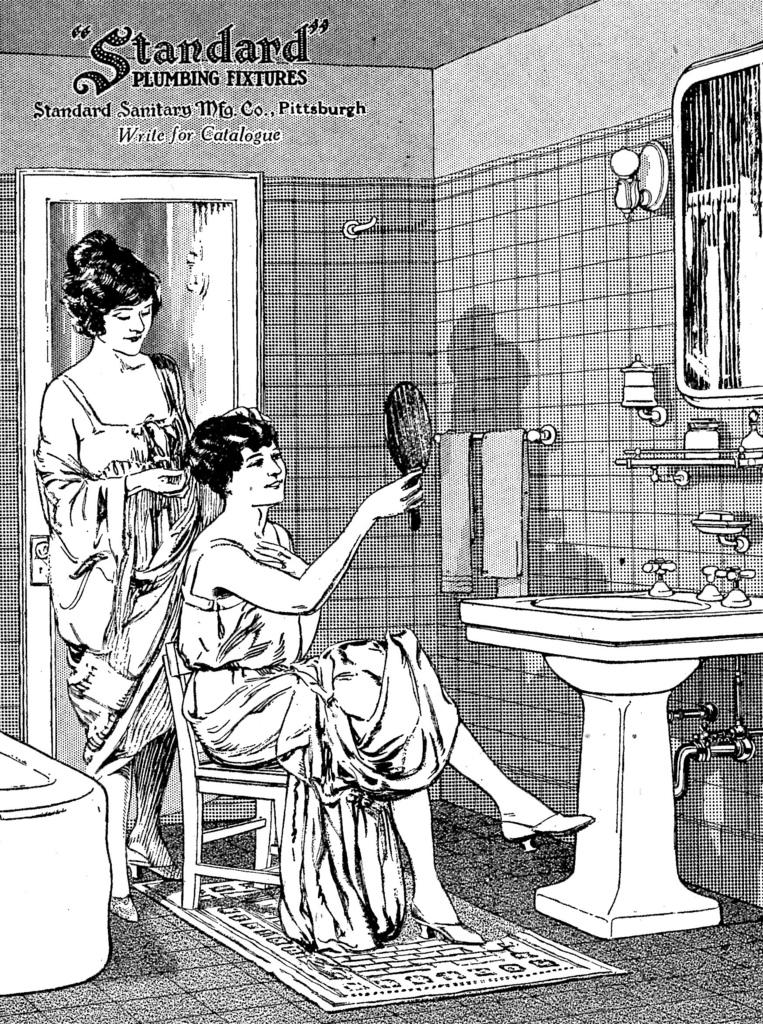What type of structure can be seen in the image? There is a wall in the image. What is another object that can be seen in the image? There is a mirror in the image. What is the purpose of the sink in the image? The sink is likely used for washing hands or other cleaning purposes. What are the taps used for in the image? The taps are used to control the flow of water in the sink. What can be used for drying hands in the image? There are towels in the image for drying hands. What is the large, water-filled container in the image? There is a bath tub in the image. What is placed on the floor near the bath tub? There is a mat in the image. How many people are present in the image? There are two people in the image. What is the woman doing in the image? A woman is holding a mirror and sitting on a chair. What type of addition problem can be solved using the numbers on the bottle in the image? There is no bottle present in the image, so no addition problem can be solved. 